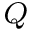Convert formula to latex. <formula><loc_0><loc_0><loc_500><loc_500>^ { Q }</formula> 